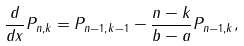Convert formula to latex. <formula><loc_0><loc_0><loc_500><loc_500>\frac { d } { d x } P _ { n , k } = P _ { n - 1 , k - 1 } - \frac { n - k } { b - a } P _ { n - 1 , k } ,</formula> 